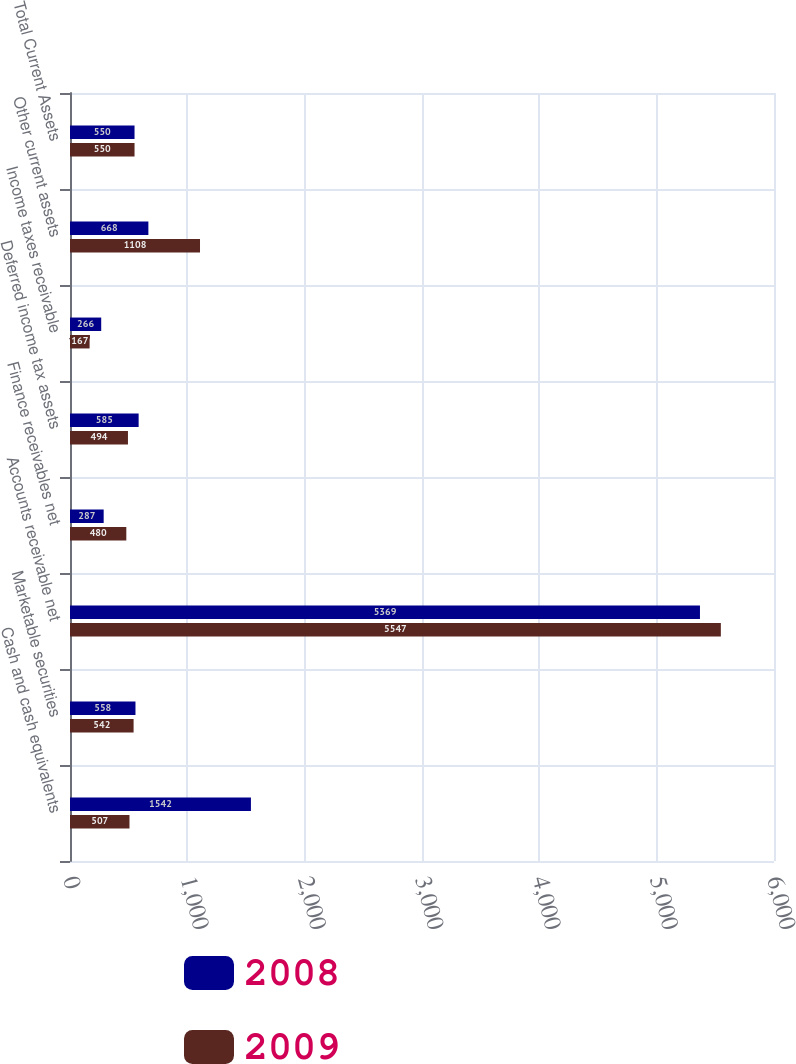Convert chart. <chart><loc_0><loc_0><loc_500><loc_500><stacked_bar_chart><ecel><fcel>Cash and cash equivalents<fcel>Marketable securities<fcel>Accounts receivable net<fcel>Finance receivables net<fcel>Deferred income tax assets<fcel>Income taxes receivable<fcel>Other current assets<fcel>Total Current Assets<nl><fcel>2008<fcel>1542<fcel>558<fcel>5369<fcel>287<fcel>585<fcel>266<fcel>668<fcel>550<nl><fcel>2009<fcel>507<fcel>542<fcel>5547<fcel>480<fcel>494<fcel>167<fcel>1108<fcel>550<nl></chart> 